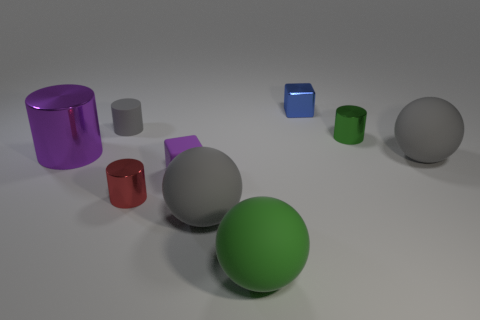Can you tell if there is a source of light within the scene? There isn't a visible light source within the image. However, the way shadows are cast and highlights appear on the objects indicates the light source is likely positioned above and slightly to the front of the scene. 